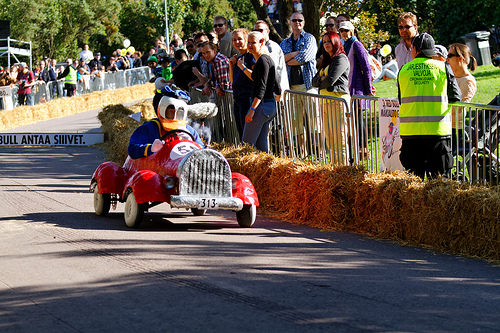<image>
Is there a driver in the wheel? No. The driver is not contained within the wheel. These objects have a different spatial relationship. 